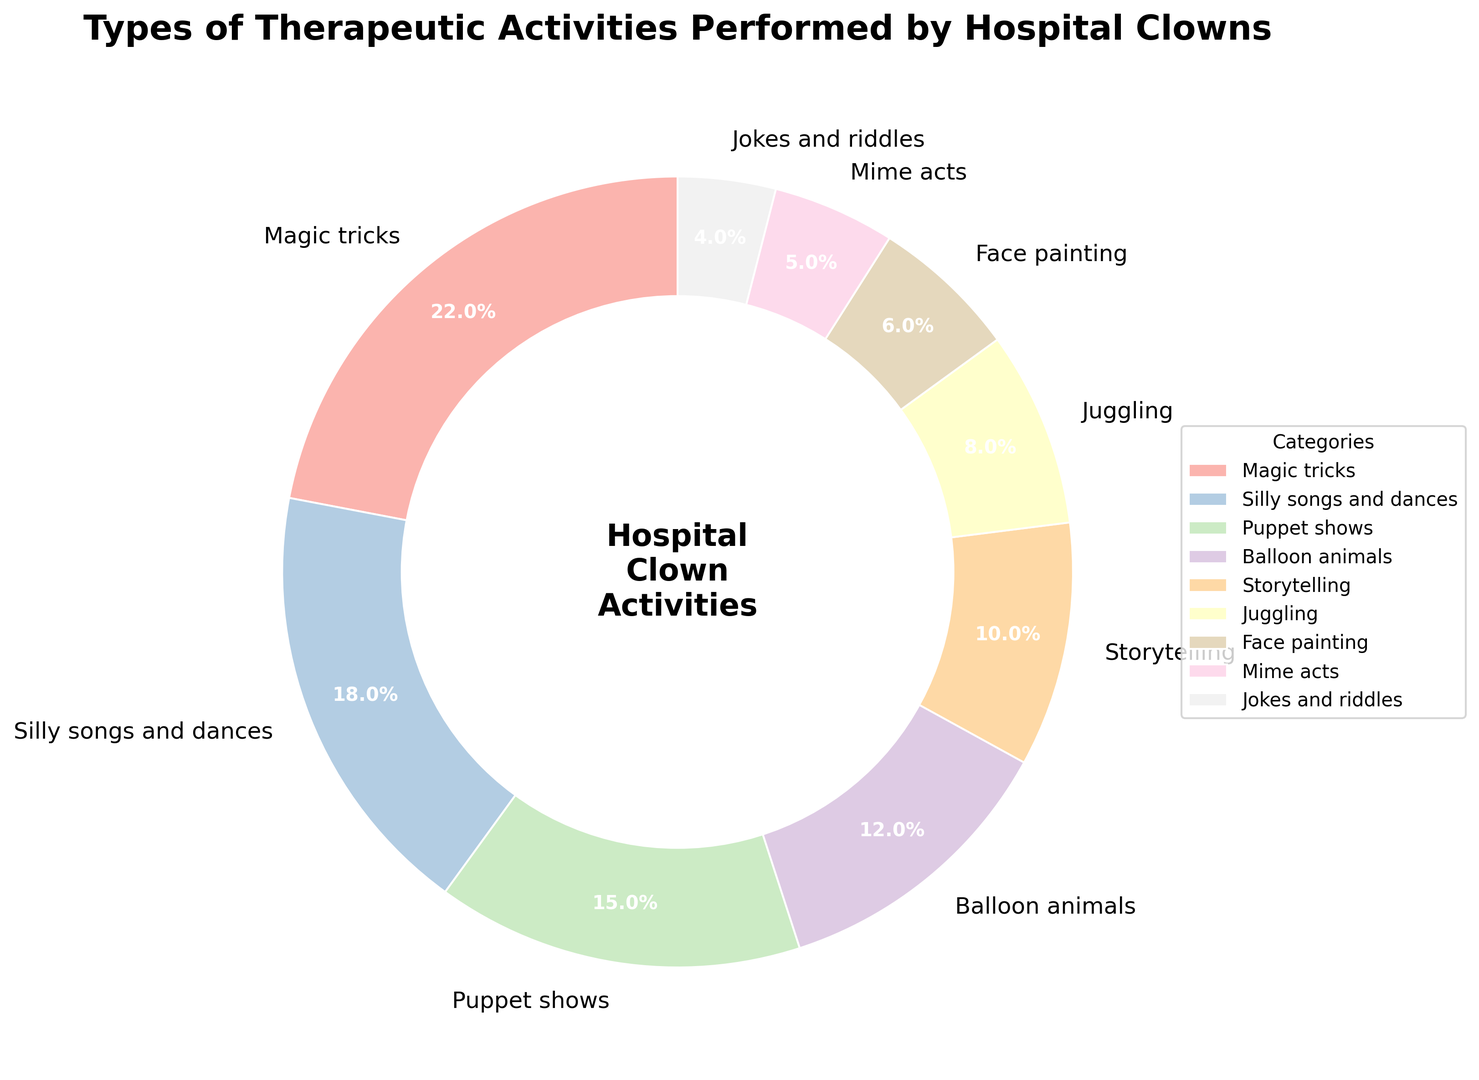What type of therapeutic activity takes up the largest percentage? First, identify all categories and their respective percentages. Then, look for the category with the highest percentage, which is clearly "Magic tricks" at 22%.
Answer: Magic tricks How much higher is the percentage of "Magic tricks" compared to "Silly songs and dances"? First, find the percentage for both categories: Magic tricks (22%) and Silly songs and dances (18%). Subtract the percentage of Silly songs and dances from Magic tricks: 22% - 18%.
Answer: 4% What is the combined percentage of "Puppet shows", "Storytelling", and "Balloon animals"? Sum the percentages of these categories: Puppet shows (15%), Storytelling (10%), and Balloon animals (12%). Total percentage is 15% + 10% + 12%.
Answer: 37% Which therapeutic activity has the lowest percentage? Identify all categories and their respective percentages. The category with the lowest percentage is "Jokes and riddles" at 4%.
Answer: Jokes and riddles How many categories contribute to more than 10% each? Look at the percentages of all categories and count how many are greater than 10%. Categories are Magic tricks (22%), Silly songs and dances (18%), Puppet shows (15%), and Balloon animals (12%), which makes 4 categories.
Answer: 4 What is the percentage difference between "Face painting" and "Mime acts"? Find the percentages for both categories: Face painting (6%) and Mime acts (5%). Subtract the percentage of Mime acts from Face painting: 6% - 5%.
Answer: 1% What percentage of activities involve physical performance (considering Magic tricks, Juggling, and Mime acts)? Sum the percentages of these categories: Magic tricks (22%), Juggling (8%), and Mime acts (5%). Total percentage is 22% + 8% + 5%.
Answer: 35% Is "Balloon animals" more or less popular than "Storytelling" and by what percentage? Find the percentages for both categories: Balloon animals (12%) and Storytelling (10%). Check the difference: 12% - 10% or 10% - 12%.
Answer: More by 2% What activity makes up a quarter of the total therapeutic activities? Calculate 25% of the total (100%). Identify the category closest to 25%, which is "Magic tricks" at 22%.
Answer: Magic tricks How much more prominent are "Magic tricks" than the sum of "Jokes and riddles" combined with "Face painting"? Sum the percentages of Jokes and riddles (4%) and Face painting (6%) to get 10%. Compare this with the percentage for Magic tricks (22%). Take the difference: 22% - 10%.
Answer: 12% 